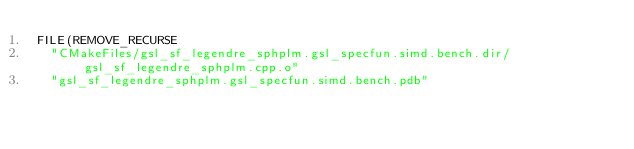<code> <loc_0><loc_0><loc_500><loc_500><_CMake_>FILE(REMOVE_RECURSE
  "CMakeFiles/gsl_sf_legendre_sphplm.gsl_specfun.simd.bench.dir/gsl_sf_legendre_sphplm.cpp.o"
  "gsl_sf_legendre_sphplm.gsl_specfun.simd.bench.pdb"</code> 